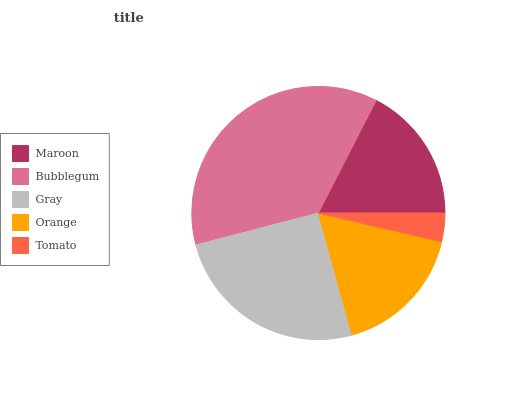Is Tomato the minimum?
Answer yes or no. Yes. Is Bubblegum the maximum?
Answer yes or no. Yes. Is Gray the minimum?
Answer yes or no. No. Is Gray the maximum?
Answer yes or no. No. Is Bubblegum greater than Gray?
Answer yes or no. Yes. Is Gray less than Bubblegum?
Answer yes or no. Yes. Is Gray greater than Bubblegum?
Answer yes or no. No. Is Bubblegum less than Gray?
Answer yes or no. No. Is Maroon the high median?
Answer yes or no. Yes. Is Maroon the low median?
Answer yes or no. Yes. Is Gray the high median?
Answer yes or no. No. Is Gray the low median?
Answer yes or no. No. 